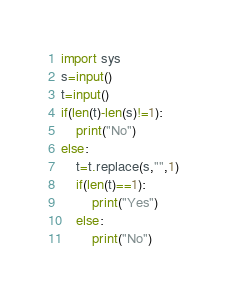<code> <loc_0><loc_0><loc_500><loc_500><_Python_>import sys 
s=input()
t=input()
if(len(t)-len(s)!=1):
    print("No")
else:
    t=t.replace(s,"",1)
    if(len(t)==1):
        print("Yes")
    else:
        print("No")



</code> 